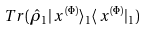<formula> <loc_0><loc_0><loc_500><loc_500>T r ( \hat { \rho } _ { 1 } | \, x ^ { ( \Phi ) } \rangle _ { 1 } \langle \, x ^ { ( \Phi ) } | _ { 1 } )</formula> 